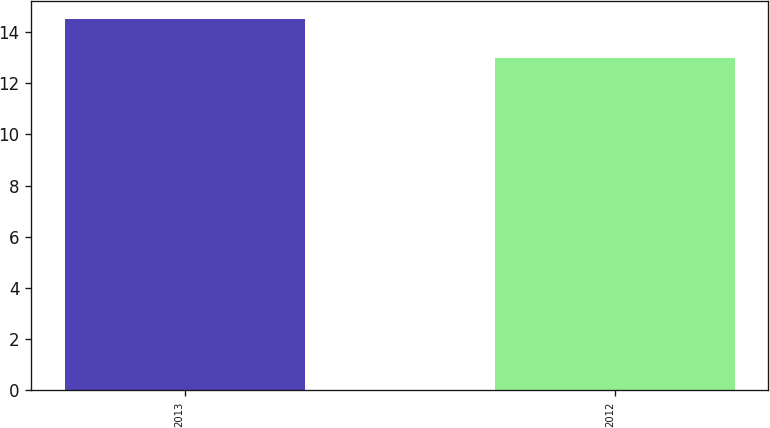<chart> <loc_0><loc_0><loc_500><loc_500><bar_chart><fcel>2013<fcel>2012<nl><fcel>14.51<fcel>12.98<nl></chart> 